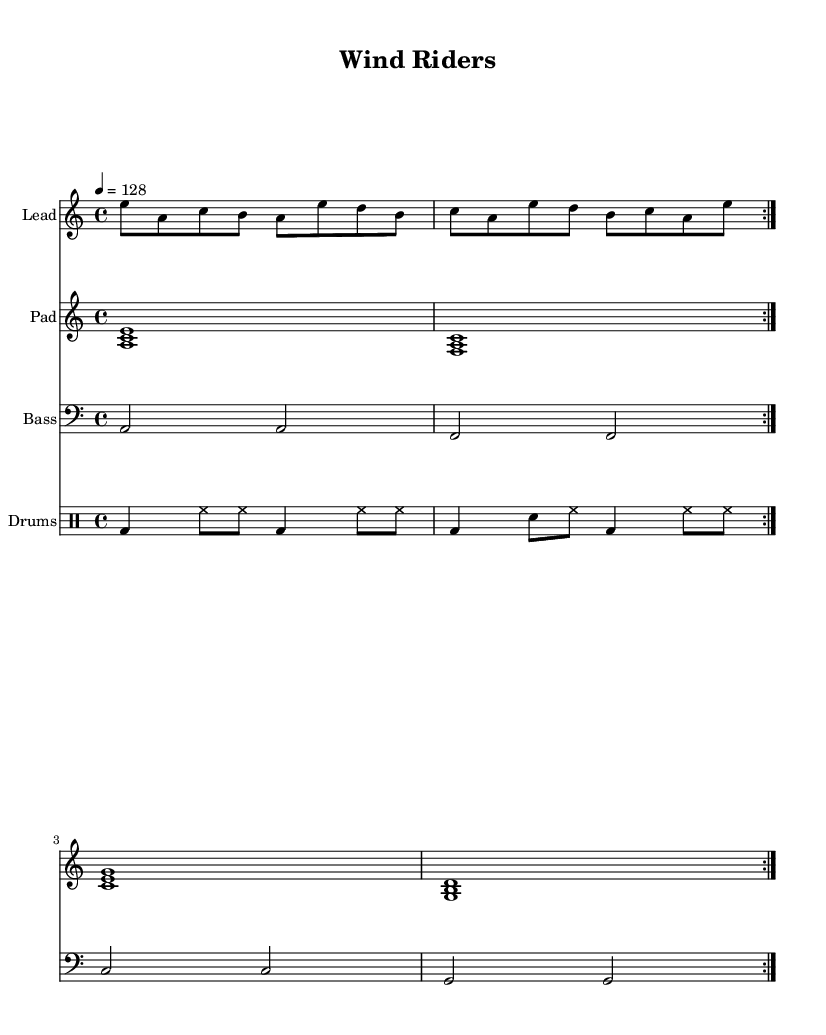What is the key signature of this music? The key signature is A minor, which has no sharps or flats.
Answer: A minor What is the time signature of this music? The time signature is indicated by 4/4, which means there are four beats per measure and the quarter note gets one beat.
Answer: 4/4 What is the tempo marking of the piece? The tempo marking is indicated as 4 = 128, meaning there are 128 beats per minute.
Answer: 128 How many volta sections are in the lead synth part? The lead synth part has two volta sections, which are indicated by the repeat markings "repeat volta 2".
Answer: 2 What is the highest note in the pad synth part? The highest note in the pad synth part is C, specifically C', which is an octave above middle C.
Answer: C' Which percussion instrument is used in the drum staff? The percussion instrument used in the drum staff includes bass drum (bd) and hi-hat (hh).
Answer: Bass drum, hi-hat What type of harmony is prevalent in the pad synth part? The harmony in the pad synth part consists of triads, which are chords formed by three notes.
Answer: Triads 